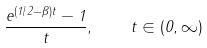Convert formula to latex. <formula><loc_0><loc_0><loc_500><loc_500>\frac { e ^ { ( 1 / 2 - \beta ) t } - 1 } t , \quad t \in ( 0 , \infty )</formula> 